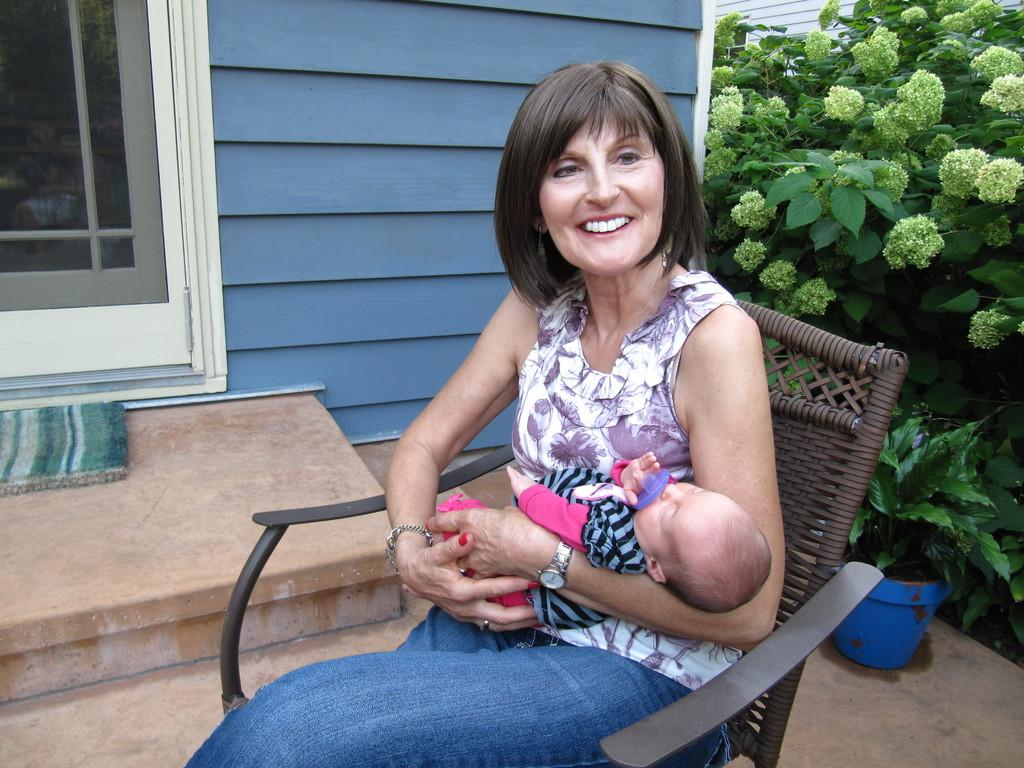What is the woman in the image doing? The woman is sitting on a chair and holding a kid in her hands. What is the woman's expression in the image? The woman is smiling. What can be seen in the background of the image? There are plants, a wall, and a window in the background. What type of net is being used by the governor in the image? There is no governor or net present in the image. How many frogs can be seen on the woman's shoulder in the image? There are no frogs present in the image. 